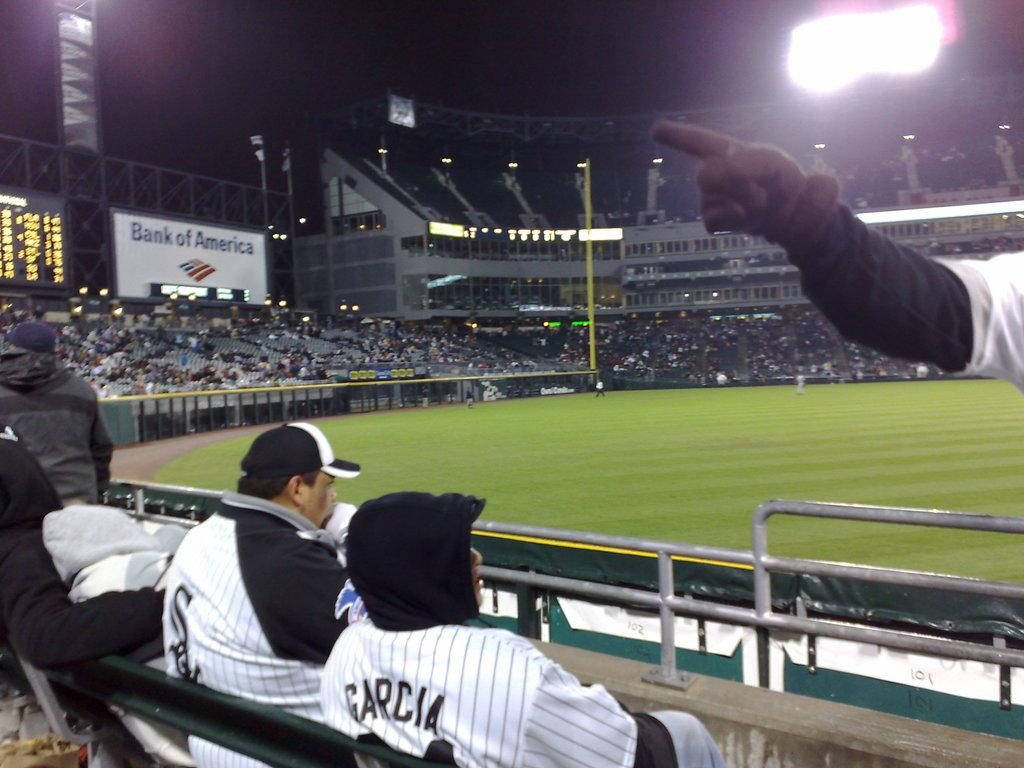<image>
Offer a succinct explanation of the picture presented. A person in a Garcia jersey  watches a baseball game. 